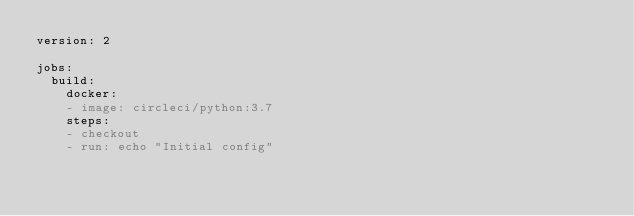Convert code to text. <code><loc_0><loc_0><loc_500><loc_500><_YAML_>version: 2

jobs:
  build:
    docker:
    - image: circleci/python:3.7
    steps:
    - checkout
    - run: echo "Initial config"
</code> 